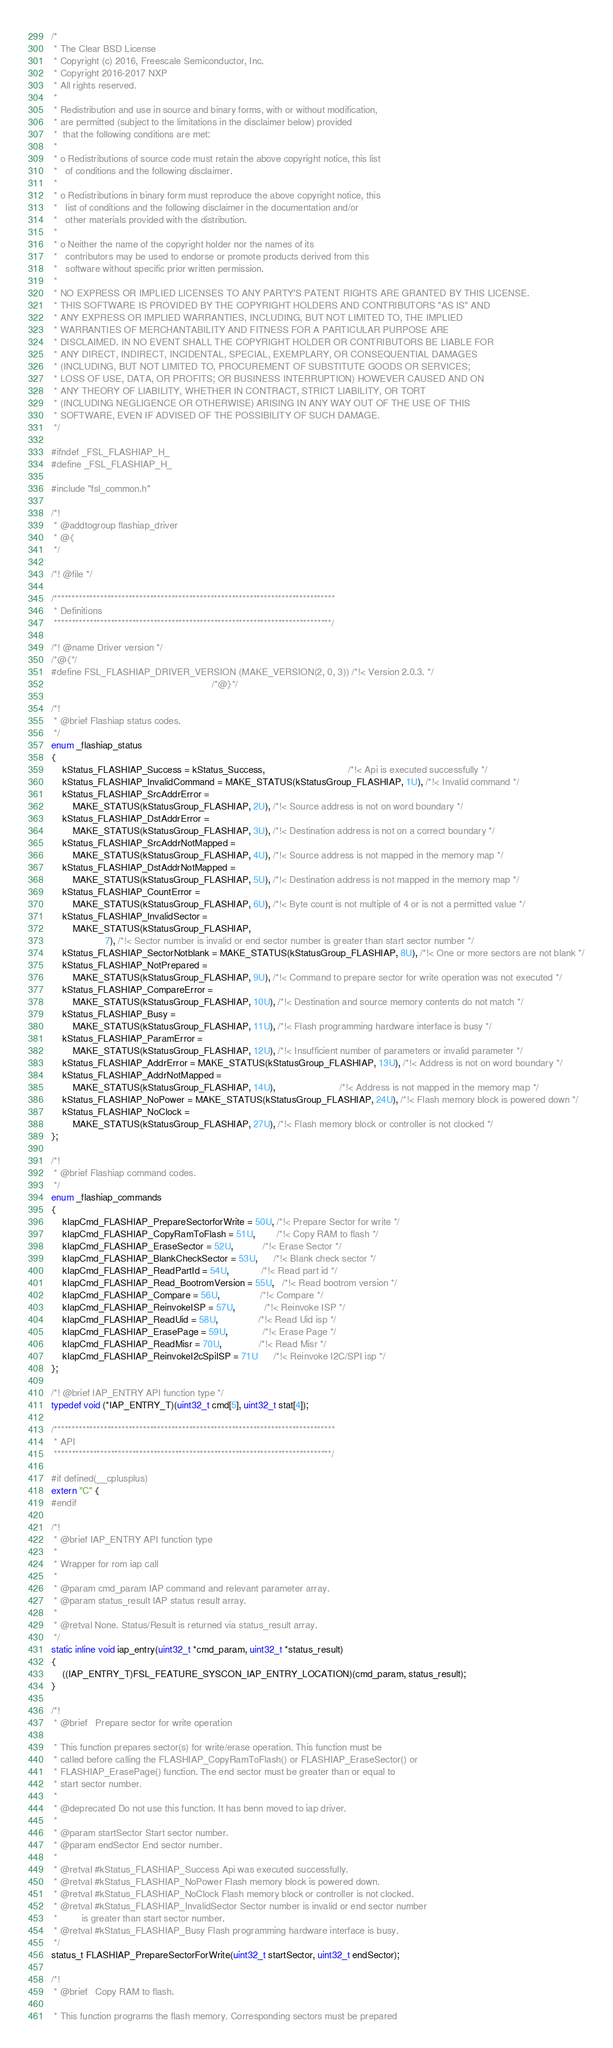Convert code to text. <code><loc_0><loc_0><loc_500><loc_500><_C_>/*
 * The Clear BSD License
 * Copyright (c) 2016, Freescale Semiconductor, Inc.
 * Copyright 2016-2017 NXP
 * All rights reserved.
 *
 * Redistribution and use in source and binary forms, with or without modification,
 * are permitted (subject to the limitations in the disclaimer below) provided
 *  that the following conditions are met:
 *
 * o Redistributions of source code must retain the above copyright notice, this list
 *   of conditions and the following disclaimer.
 *
 * o Redistributions in binary form must reproduce the above copyright notice, this
 *   list of conditions and the following disclaimer in the documentation and/or
 *   other materials provided with the distribution.
 *
 * o Neither the name of the copyright holder nor the names of its
 *   contributors may be used to endorse or promote products derived from this
 *   software without specific prior written permission.
 *
 * NO EXPRESS OR IMPLIED LICENSES TO ANY PARTY'S PATENT RIGHTS ARE GRANTED BY THIS LICENSE.
 * THIS SOFTWARE IS PROVIDED BY THE COPYRIGHT HOLDERS AND CONTRIBUTORS "AS IS" AND
 * ANY EXPRESS OR IMPLIED WARRANTIES, INCLUDING, BUT NOT LIMITED TO, THE IMPLIED
 * WARRANTIES OF MERCHANTABILITY AND FITNESS FOR A PARTICULAR PURPOSE ARE
 * DISCLAIMED. IN NO EVENT SHALL THE COPYRIGHT HOLDER OR CONTRIBUTORS BE LIABLE FOR
 * ANY DIRECT, INDIRECT, INCIDENTAL, SPECIAL, EXEMPLARY, OR CONSEQUENTIAL DAMAGES
 * (INCLUDING, BUT NOT LIMITED TO, PROCUREMENT OF SUBSTITUTE GOODS OR SERVICES;
 * LOSS OF USE, DATA, OR PROFITS; OR BUSINESS INTERRUPTION) HOWEVER CAUSED AND ON
 * ANY THEORY OF LIABILITY, WHETHER IN CONTRACT, STRICT LIABILITY, OR TORT
 * (INCLUDING NEGLIGENCE OR OTHERWISE) ARISING IN ANY WAY OUT OF THE USE OF THIS
 * SOFTWARE, EVEN IF ADVISED OF THE POSSIBILITY OF SUCH DAMAGE.
 */

#ifndef _FSL_FLASHIAP_H_
#define _FSL_FLASHIAP_H_

#include "fsl_common.h"

/*!
 * @addtogroup flashiap_driver
 * @{
 */

/*! @file */

/*******************************************************************************
 * Definitions
 ******************************************************************************/

/*! @name Driver version */
/*@{*/
#define FSL_FLASHIAP_DRIVER_VERSION (MAKE_VERSION(2, 0, 3)) /*!< Version 2.0.3. */
                                                            /*@}*/

/*!
 * @brief Flashiap status codes.
 */
enum _flashiap_status
{
    kStatus_FLASHIAP_Success = kStatus_Success,                               /*!< Api is executed successfully */
    kStatus_FLASHIAP_InvalidCommand = MAKE_STATUS(kStatusGroup_FLASHIAP, 1U), /*!< Invalid command */
    kStatus_FLASHIAP_SrcAddrError =
        MAKE_STATUS(kStatusGroup_FLASHIAP, 2U), /*!< Source address is not on word boundary */
    kStatus_FLASHIAP_DstAddrError =
        MAKE_STATUS(kStatusGroup_FLASHIAP, 3U), /*!< Destination address is not on a correct boundary */
    kStatus_FLASHIAP_SrcAddrNotMapped =
        MAKE_STATUS(kStatusGroup_FLASHIAP, 4U), /*!< Source address is not mapped in the memory map */
    kStatus_FLASHIAP_DstAddrNotMapped =
        MAKE_STATUS(kStatusGroup_FLASHIAP, 5U), /*!< Destination address is not mapped in the memory map */
    kStatus_FLASHIAP_CountError =
        MAKE_STATUS(kStatusGroup_FLASHIAP, 6U), /*!< Byte count is not multiple of 4 or is not a permitted value */
    kStatus_FLASHIAP_InvalidSector =
        MAKE_STATUS(kStatusGroup_FLASHIAP,
                    7), /*!< Sector number is invalid or end sector number is greater than start sector number */
    kStatus_FLASHIAP_SectorNotblank = MAKE_STATUS(kStatusGroup_FLASHIAP, 8U), /*!< One or more sectors are not blank */
    kStatus_FLASHIAP_NotPrepared =
        MAKE_STATUS(kStatusGroup_FLASHIAP, 9U), /*!< Command to prepare sector for write operation was not executed */
    kStatus_FLASHIAP_CompareError =
        MAKE_STATUS(kStatusGroup_FLASHIAP, 10U), /*!< Destination and source memory contents do not match */
    kStatus_FLASHIAP_Busy =
        MAKE_STATUS(kStatusGroup_FLASHIAP, 11U), /*!< Flash programming hardware interface is busy */
    kStatus_FLASHIAP_ParamError =
        MAKE_STATUS(kStatusGroup_FLASHIAP, 12U), /*!< Insufficient number of parameters or invalid parameter */
    kStatus_FLASHIAP_AddrError = MAKE_STATUS(kStatusGroup_FLASHIAP, 13U), /*!< Address is not on word boundary */
    kStatus_FLASHIAP_AddrNotMapped =
        MAKE_STATUS(kStatusGroup_FLASHIAP, 14U),                        /*!< Address is not mapped in the memory map */
    kStatus_FLASHIAP_NoPower = MAKE_STATUS(kStatusGroup_FLASHIAP, 24U), /*!< Flash memory block is powered down */
    kStatus_FLASHIAP_NoClock =
        MAKE_STATUS(kStatusGroup_FLASHIAP, 27U), /*!< Flash memory block or controller is not clocked */
};

/*!
 * @brief Flashiap command codes.
 */
enum _flashiap_commands
{
    kIapCmd_FLASHIAP_PrepareSectorforWrite = 50U, /*!< Prepare Sector for write */
    kIapCmd_FLASHIAP_CopyRamToFlash = 51U,        /*!< Copy RAM to flash */
    kIapCmd_FLASHIAP_EraseSector = 52U,           /*!< Erase Sector */
    kIapCmd_FLASHIAP_BlankCheckSector = 53U,      /*!< Blank check sector */
    kIapCmd_FLASHIAP_ReadPartId = 54U,            /*!< Read part id */
    kIapCmd_FLASHIAP_Read_BootromVersion = 55U,   /*!< Read bootrom version */
    kIapCmd_FLASHIAP_Compare = 56U,               /*!< Compare */
    kIapCmd_FLASHIAP_ReinvokeISP = 57U,           /*!< Reinvoke ISP */
    kIapCmd_FLASHIAP_ReadUid = 58U,               /*!< Read Uid isp */
    kIapCmd_FLASHIAP_ErasePage = 59U,             /*!< Erase Page */
    kIapCmd_FLASHIAP_ReadMisr = 70U,              /*!< Read Misr */
    kIapCmd_FLASHIAP_ReinvokeI2cSpiISP = 71U      /*!< Reinvoke I2C/SPI isp */
};

/*! @brief IAP_ENTRY API function type */
typedef void (*IAP_ENTRY_T)(uint32_t cmd[5], uint32_t stat[4]);

/*******************************************************************************
 * API
 ******************************************************************************/

#if defined(__cplusplus)
extern "C" {
#endif

/*!
 * @brief IAP_ENTRY API function type
 *
 * Wrapper for rom iap call
 *
 * @param cmd_param IAP command and relevant parameter array.
 * @param status_result IAP status result array.
 *
 * @retval None. Status/Result is returned via status_result array.
 */
static inline void iap_entry(uint32_t *cmd_param, uint32_t *status_result)
{
    ((IAP_ENTRY_T)FSL_FEATURE_SYSCON_IAP_ENTRY_LOCATION)(cmd_param, status_result);
}

/*!
 * @brief	Prepare sector for write operation

 * This function prepares sector(s) for write/erase operation. This function must be
 * called before calling the FLASHIAP_CopyRamToFlash() or FLASHIAP_EraseSector() or
 * FLASHIAP_ErasePage() function. The end sector must be greater than or equal to
 * start sector number.
 *
 * @deprecated Do not use this function. It has benn moved to iap driver.
 *
 * @param startSector Start sector number.
 * @param endSector End sector number.
 *
 * @retval #kStatus_FLASHIAP_Success Api was executed successfully.
 * @retval #kStatus_FLASHIAP_NoPower Flash memory block is powered down.
 * @retval #kStatus_FLASHIAP_NoClock Flash memory block or controller is not clocked.
 * @retval #kStatus_FLASHIAP_InvalidSector Sector number is invalid or end sector number
 *         is greater than start sector number.
 * @retval #kStatus_FLASHIAP_Busy Flash programming hardware interface is busy.
 */
status_t FLASHIAP_PrepareSectorForWrite(uint32_t startSector, uint32_t endSector);

/*!
 * @brief	Copy RAM to flash.

 * This function programs the flash memory. Corresponding sectors must be prepared</code> 